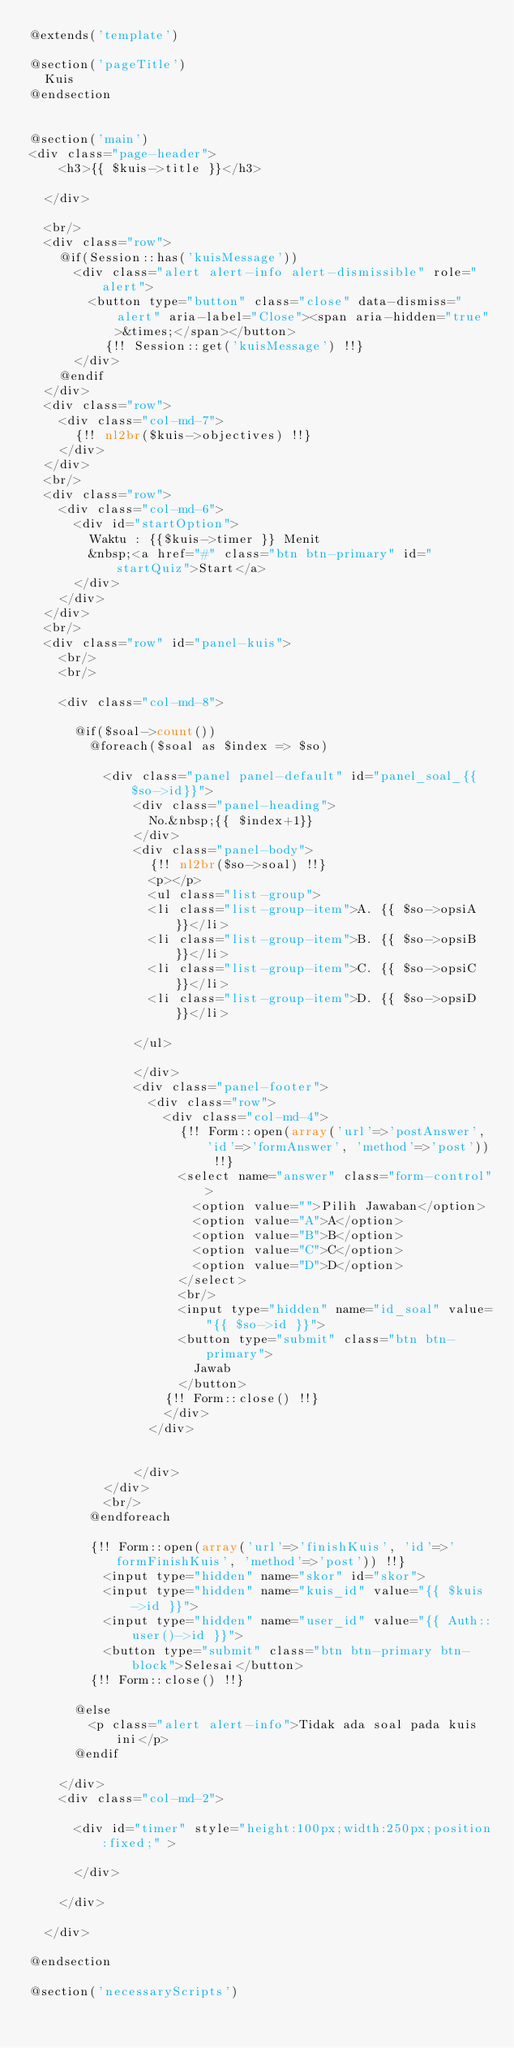Convert code to text. <code><loc_0><loc_0><loc_500><loc_500><_PHP_>@extends('template')

@section('pageTitle')
	Kuis
@endsection


@section('main')
<div class="page-header">
		<h3>{{ $kuis->title }}</h3>
		
	</div>
	
	<br/>
	<div class="row">
		@if(Session::has('kuisMessage'))
			<div class="alert alert-info alert-dismissible" role="alert">
				<button type="button" class="close" data-dismiss="alert" aria-label="Close"><span aria-hidden="true">&times;</span></button>
			  	{!! Session::get('kuisMessage') !!}
			</div>
		@endif
	</div>
	<div class="row">
		<div class="col-md-7">
			{!! nl2br($kuis->objectives) !!}
		</div>
	</div>
	<br/>
	<div class="row">
		<div class="col-md-6">
			<div id="startOption">
				Waktu : {{$kuis->timer }} Menit
				&nbsp;<a href="#" class="btn btn-primary" id="startQuiz">Start</a>
			</div>
		</div>
	</div>
	<br/>
	<div class="row" id="panel-kuis">
		<br/>
		<br/>

		<div class="col-md-8">
			
			@if($soal->count())
				@foreach($soal as $index => $so)

					<div class="panel panel-default" id="panel_soal_{{$so->id}}">
					  	<div class="panel-heading">
					    	No.&nbsp;{{ $index+1}}
					  	</div>
					  	<div class="panel-body">
					  		{!! nl2br($so->soal) !!}
					  		<p></p>
					    	<ul class="list-group">
							  <li class="list-group-item">A. {{ $so->opsiA }}</li>
							  <li class="list-group-item">B. {{ $so->opsiB }}</li>
							  <li class="list-group-item">C. {{ $so->opsiC }}</li>
							  <li class="list-group-item">D. {{ $so->opsiD }}</li>
							  
							</ul>
							
					  	</div>
					  	<div class="panel-footer">
					  		<div class="row">
					  			<div class="col-md-4">
					  				{!! Form::open(array('url'=>'postAnswer', 'id'=>'formAnswer', 'method'=>'post')) !!}
										<select name="answer" class="form-control">
											<option value="">Pilih Jawaban</option>
											<option value="A">A</option>
											<option value="B">B</option>
											<option value="C">C</option>
											<option value="D">D</option>
										</select>
										<br/>
										<input type="hidden" name="id_soal" value="{{ $so->id }}">
										<button type="submit" class="btn btn-primary">
											Jawab
										</button>
									{!! Form::close() !!}
							  	</div>
					  		</div>


					  	</div>
					</div>
					<br/>
				@endforeach

				{!! Form::open(array('url'=>'finishKuis', 'id'=>'formFinishKuis', 'method'=>'post')) !!}
					<input type="hidden" name="skor" id="skor">
					<input type="hidden" name="kuis_id" value="{{ $kuis->id }}">
					<input type="hidden" name="user_id" value="{{ Auth::user()->id }}">
					<button type="submit" class="btn btn-primary btn-block">Selesai</button>
				{!! Form::close() !!}

			@else
				<p class="alert alert-info">Tidak ada soal pada kuis ini</p>
			@endif
				
		</div>
		<div class="col-md-2">

			<div id="timer" style="height:100px;width:250px;position:fixed;" >

			</div>
			
		</div>
		
	</div>

@endsection

@section('necessaryScripts')
</code> 